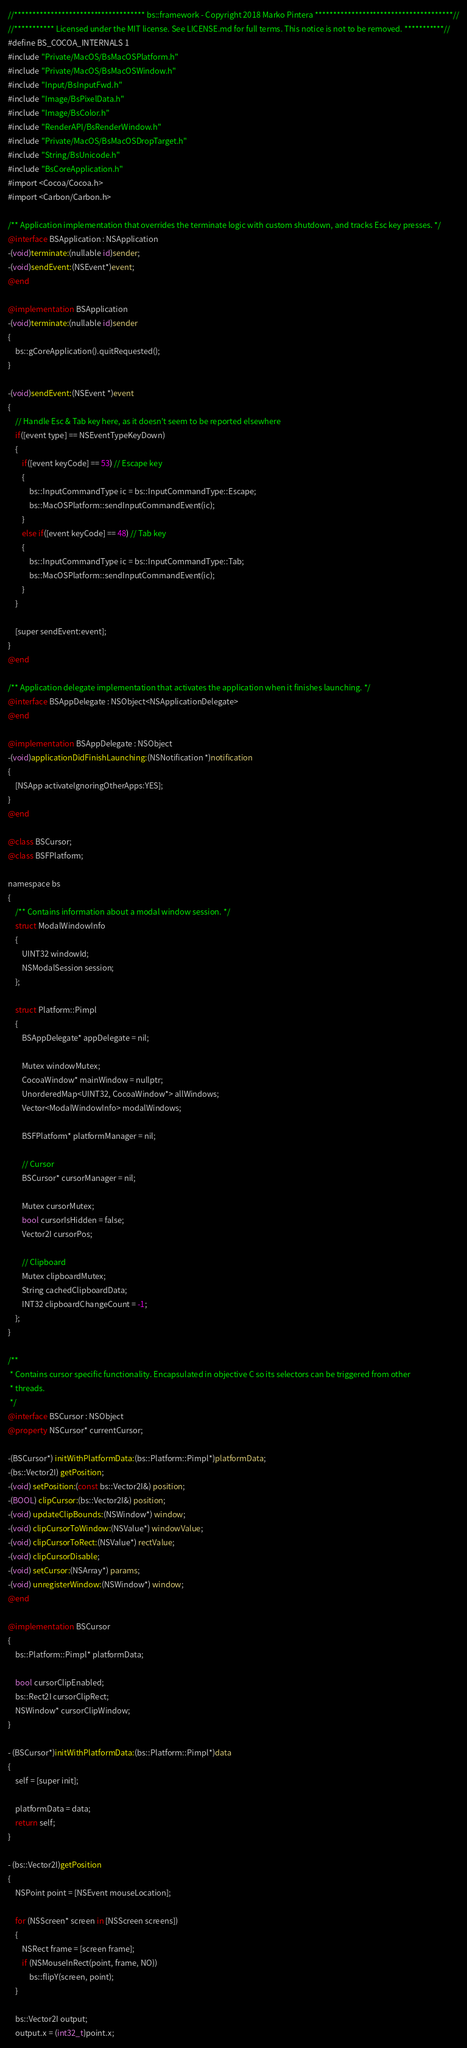Convert code to text. <code><loc_0><loc_0><loc_500><loc_500><_ObjectiveC_>//************************************ bs::framework - Copyright 2018 Marko Pintera **************************************//
//*********** Licensed under the MIT license. See LICENSE.md for full terms. This notice is not to be removed. ***********//
#define BS_COCOA_INTERNALS 1
#include "Private/MacOS/BsMacOSPlatform.h"
#include "Private/MacOS/BsMacOSWindow.h"
#include "Input/BsInputFwd.h"
#include "Image/BsPixelData.h"
#include "Image/BsColor.h"
#include "RenderAPI/BsRenderWindow.h"
#include "Private/MacOS/BsMacOSDropTarget.h"
#include "String/BsUnicode.h"
#include "BsCoreApplication.h"
#import <Cocoa/Cocoa.h>
#import <Carbon/Carbon.h>

/** Application implementation that overrides the terminate logic with custom shutdown, and tracks Esc key presses. */
@interface BSApplication : NSApplication
-(void)terminate:(nullable id)sender;
-(void)sendEvent:(NSEvent*)event;
@end

@implementation BSApplication
-(void)terminate:(nullable id)sender
{
	bs::gCoreApplication().quitRequested();
}

-(void)sendEvent:(NSEvent *)event
{
	// Handle Esc & Tab key here, as it doesn't seem to be reported elsewhere
	if([event type] == NSEventTypeKeyDown)
	{
		if([event keyCode] == 53) // Escape key
		{
			bs::InputCommandType ic = bs::InputCommandType::Escape;
			bs::MacOSPlatform::sendInputCommandEvent(ic);
		}
		else if([event keyCode] == 48) // Tab key
		{
			bs::InputCommandType ic = bs::InputCommandType::Tab;
			bs::MacOSPlatform::sendInputCommandEvent(ic);
		}
	}

	[super sendEvent:event];
}
@end

/** Application delegate implementation that activates the application when it finishes launching. */
@interface BSAppDelegate : NSObject<NSApplicationDelegate>
@end

@implementation BSAppDelegate : NSObject
-(void)applicationDidFinishLaunching:(NSNotification *)notification
{
	[NSApp activateIgnoringOtherApps:YES];
}
@end

@class BSCursor;
@class BSFPlatform;

namespace bs
{
	/** Contains information about a modal window session. */
	struct ModalWindowInfo
	{
		UINT32 windowId;
		NSModalSession session;
	};

	struct Platform::Pimpl
	{
		BSAppDelegate* appDelegate = nil;

		Mutex windowMutex;
		CocoaWindow* mainWindow = nullptr;
		UnorderedMap<UINT32, CocoaWindow*> allWindows;
		Vector<ModalWindowInfo> modalWindows;

		BSFPlatform* platformManager = nil;

		// Cursor
		BSCursor* cursorManager = nil;

		Mutex cursorMutex;
		bool cursorIsHidden = false;
		Vector2I cursorPos;

		// Clipboard
		Mutex clipboardMutex;
		String cachedClipboardData;
		INT32 clipboardChangeCount = -1;
	};
}

/**
 * Contains cursor specific functionality. Encapsulated in objective C so its selectors can be triggered from other
 * threads.
 */
@interface BSCursor : NSObject
@property NSCursor* currentCursor;

-(BSCursor*) initWithPlatformData:(bs::Platform::Pimpl*)platformData;
-(bs::Vector2I) getPosition;
-(void) setPosition:(const bs::Vector2I&) position;
-(BOOL) clipCursor:(bs::Vector2I&) position;
-(void) updateClipBounds:(NSWindow*) window;
-(void) clipCursorToWindow:(NSValue*) windowValue;
-(void) clipCursorToRect:(NSValue*) rectValue;
-(void) clipCursorDisable;
-(void) setCursor:(NSArray*) params;
-(void) unregisterWindow:(NSWindow*) window;
@end

@implementation BSCursor
{
	bs::Platform::Pimpl* platformData;

	bool cursorClipEnabled;
	bs::Rect2I cursorClipRect;
	NSWindow* cursorClipWindow;
}

- (BSCursor*)initWithPlatformData:(bs::Platform::Pimpl*)data
{
	self = [super init];

	platformData = data;
	return self;
}

- (bs::Vector2I)getPosition
{
	NSPoint point = [NSEvent mouseLocation];

	for (NSScreen* screen in [NSScreen screens])
	{
		NSRect frame = [screen frame];
		if (NSMouseInRect(point, frame, NO))
			bs::flipY(screen, point);
	}

	bs::Vector2I output;
	output.x = (int32_t)point.x;</code> 